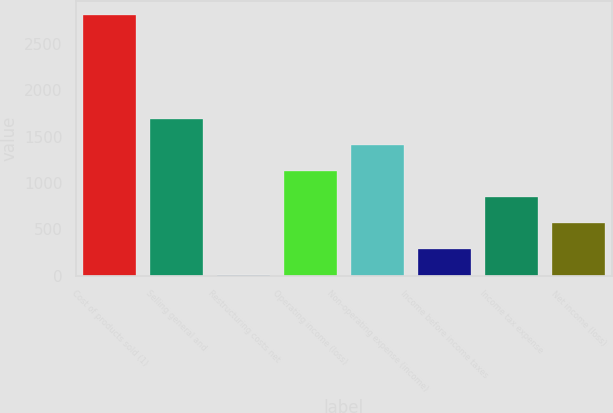Convert chart to OTSL. <chart><loc_0><loc_0><loc_500><loc_500><bar_chart><fcel>Cost of products sold (1)<fcel>Selling general and<fcel>Restructuring costs net<fcel>Operating income (loss)<fcel>Non-operating expense (income)<fcel>Income before income taxes<fcel>Income tax expense<fcel>Net income (loss)<nl><fcel>2812.5<fcel>1691.3<fcel>9.5<fcel>1130.7<fcel>1411<fcel>289.8<fcel>850.4<fcel>570.1<nl></chart> 